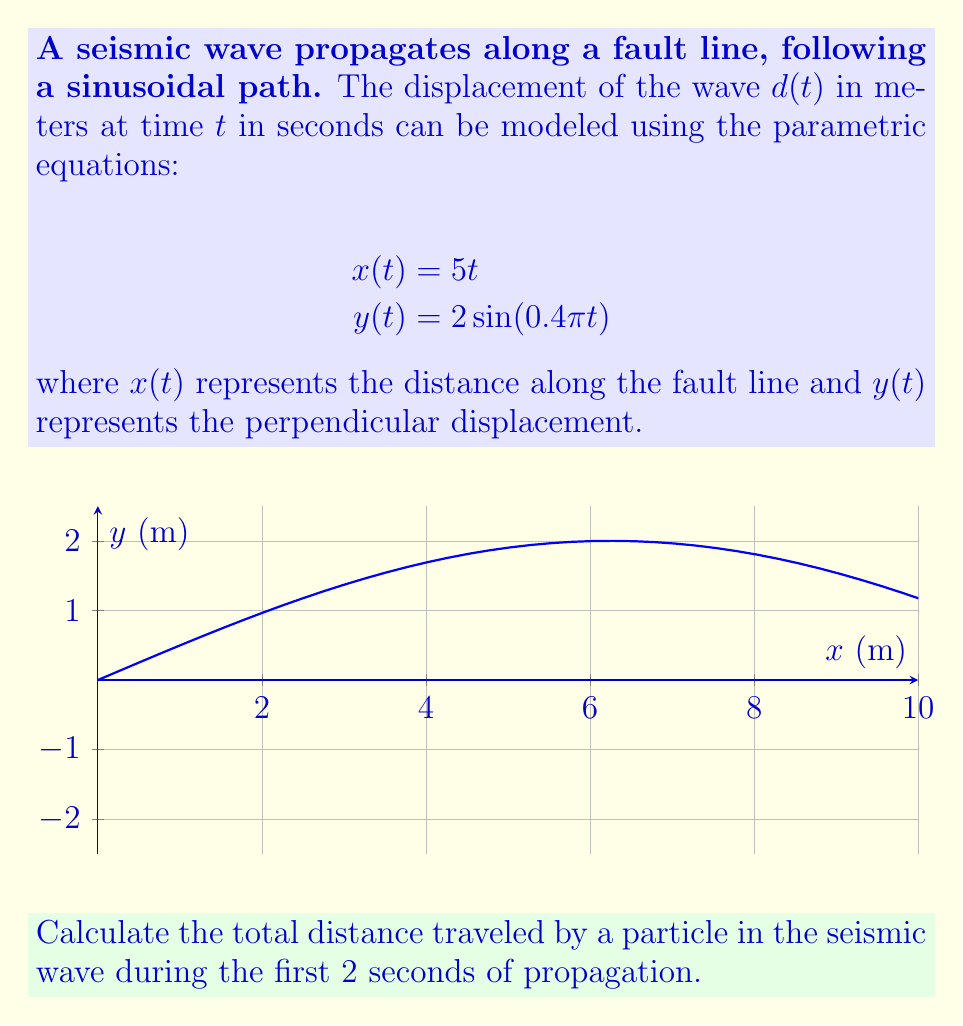Solve this math problem. To solve this problem, we need to follow these steps:

1) The particle's path is described by the parametric equations. To find the total distance traveled, we need to calculate the arc length of the curve from $t=0$ to $t=2$.

2) The formula for arc length $L$ of a parametric curve from $t=a$ to $t=b$ is:

   $$L = \int_a^b \sqrt{\left(\frac{dx}{dt}\right)^2 + \left(\frac{dy}{dt}\right)^2} dt$$

3) First, let's calculate $\frac{dx}{dt}$ and $\frac{dy}{dt}$:
   
   $$\frac{dx}{dt} = 5$$
   $$\frac{dy}{dt} = 2 \cdot 0.4\pi \cos(0.4\pi t) = 0.8\pi \cos(0.4\pi t)$$

4) Now, let's substitute these into the arc length formula:

   $$L = \int_0^2 \sqrt{5^2 + (0.8\pi \cos(0.4\pi t))^2} dt$$

5) This integral is complex and doesn't have a simple analytical solution. We need to use numerical integration methods to solve it accurately.

6) Using a numerical integration method (like Simpson's rule or a computer algebra system), we get:

   $$L \approx 10.05 \text{ meters}$$

This result makes sense because the straight-line distance along the fault (x-direction) in 2 seconds is 10 meters, and the sinusoidal path adds a small amount of extra distance.
Answer: $10.05 \text{ meters}$ 